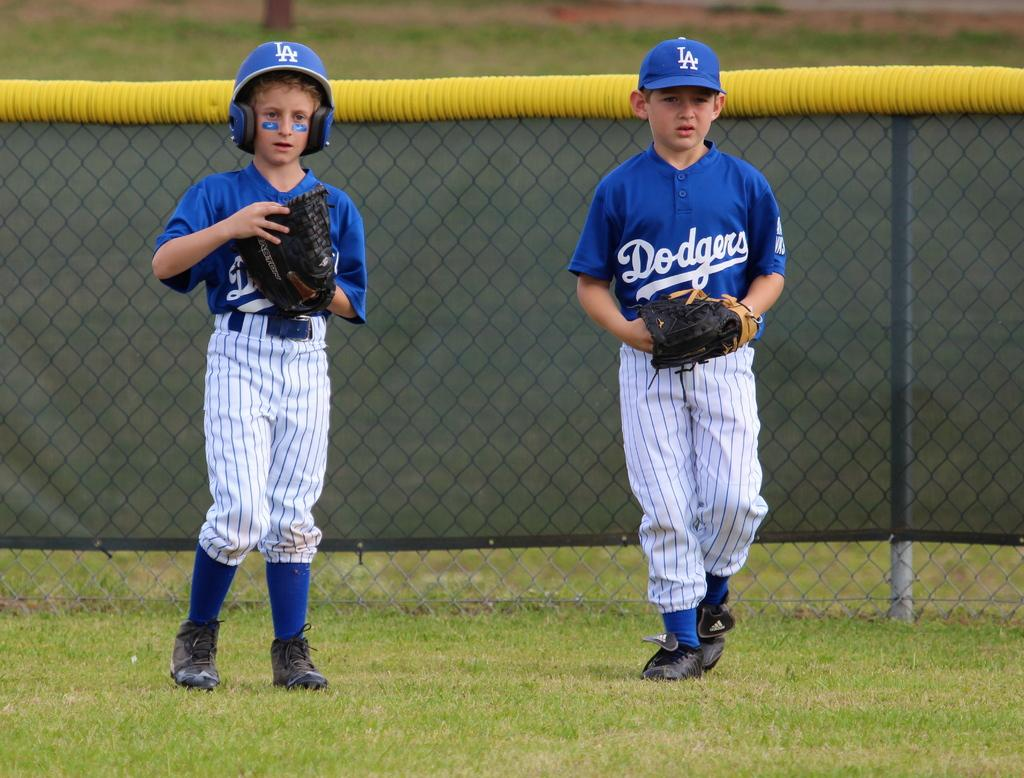<image>
Share a concise interpretation of the image provided. Two little league baseball players dressed in LA Dodgers uniforms. 